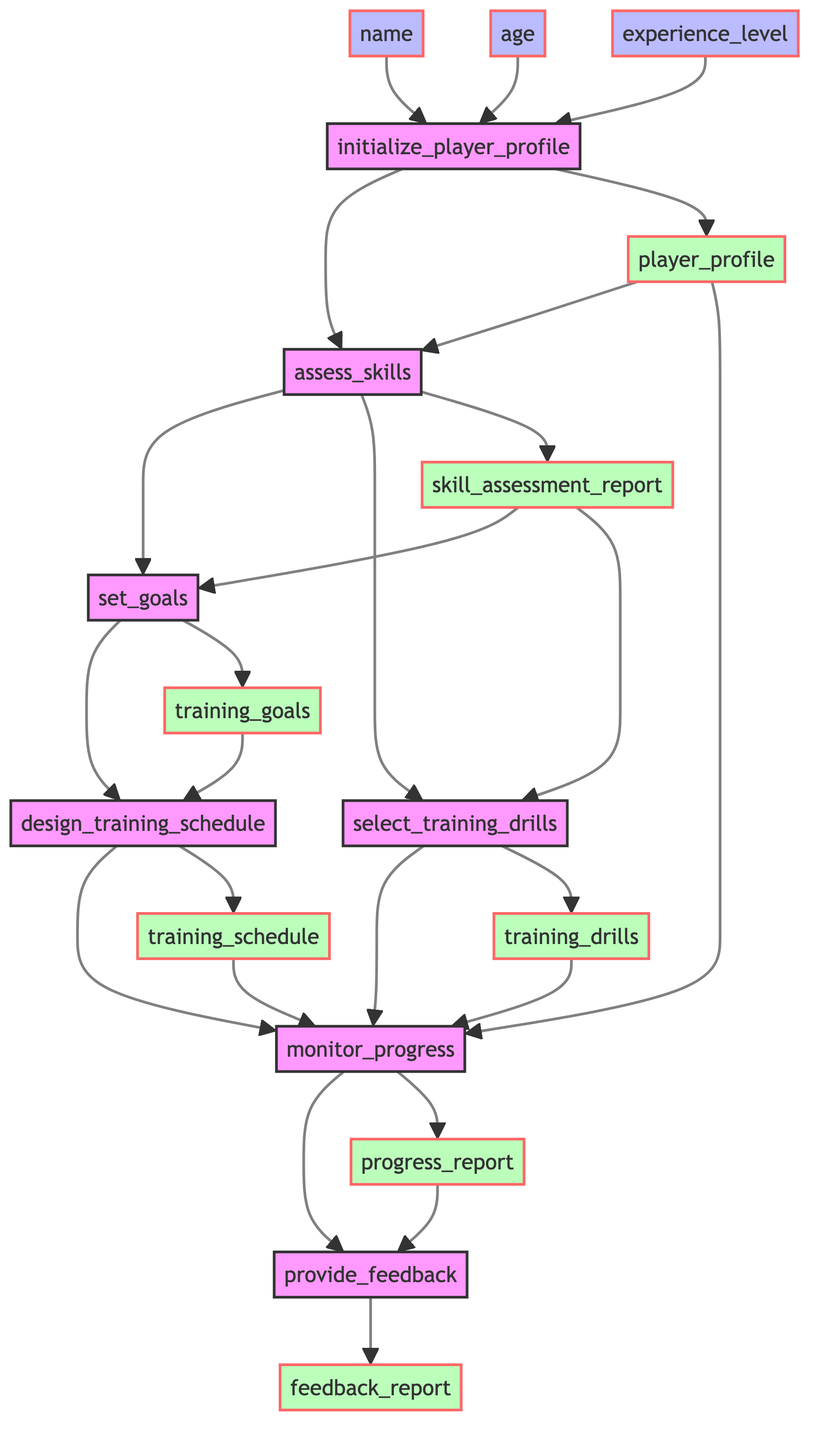What is the first step in the process? The first step in the process, as denoted at the top of the flowchart, is "initialize_player_profile." This step is essential as it sets up the foundation for creating a profile of the young player, allowing further steps to follow.
Answer: initialize_player_profile How many nodes are in the diagram? Counting the steps and outputs listed in the diagram, there are a total of 7 nodes: initialize_player_profile, assess_skills, set_goals, design_training_schedule, select_training_drills, monitor_progress, provide_feedback.
Answer: 7 What input is required to initialize the player profile? The diagram specifies three required inputs for the "initialize_player_profile" node: name, age, and experience level. These inputs are necessary for creating the player's profile.
Answer: name, age, experience_level What are the outputs of the "assess_skills" step? According to the flowchart, the output of the "assess_skills" step is "skill_assessment_report." This report is crucial for setting subsequent training goals based on the evaluation of the player's skills.
Answer: skill_assessment_report Which two steps feed into the "monitor_progress"? The "monitor_progress" node receives inputs from two steps: "design_training_schedule" and "select_training_drills." This means that both the training schedule and the chosen drills are essential for evaluating the player's progress.
Answer: design_training_schedule, select_training_drills What are the inputs needed to monitor progress? To monitor progress, the "monitor_progress" step requires three inputs: player profile, training schedule, and training drills. This comprehensive data collection is essential for a thorough assessment of the player's advancements.
Answer: player_profile, training_schedule, training_drills How many outputs does the process ultimately produce? The entire process, as indicated in the flowchart, leads to a single final output from the last step, which is "feedback_report." This report summarizes the player's progress and provides feedback.
Answer: 1 What is the purpose of the "provide_feedback" step? The "provide_feedback" step aims to offer constructive feedback and motivational support to the player based on their progress report. This step is crucial for encouraging the player's development and sustained interest in the game.
Answer: Constructive feedback and motivational support 